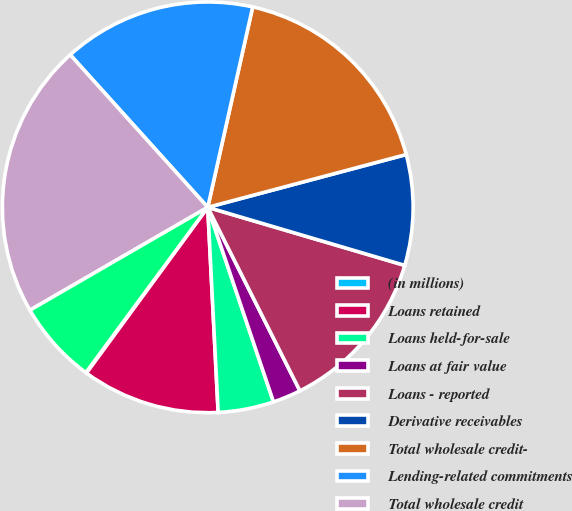Convert chart. <chart><loc_0><loc_0><loc_500><loc_500><pie_chart><fcel>(in millions)<fcel>Loans retained<fcel>Loans held-for-sale<fcel>Loans at fair value<fcel>Loans - reported<fcel>Derivative receivables<fcel>Total wholesale credit-<fcel>Lending-related commitments<fcel>Total wholesale credit<fcel>Credit Portfolio Management<nl><fcel>0.06%<fcel>10.86%<fcel>4.38%<fcel>2.22%<fcel>13.03%<fcel>8.7%<fcel>17.35%<fcel>15.19%<fcel>21.67%<fcel>6.54%<nl></chart> 